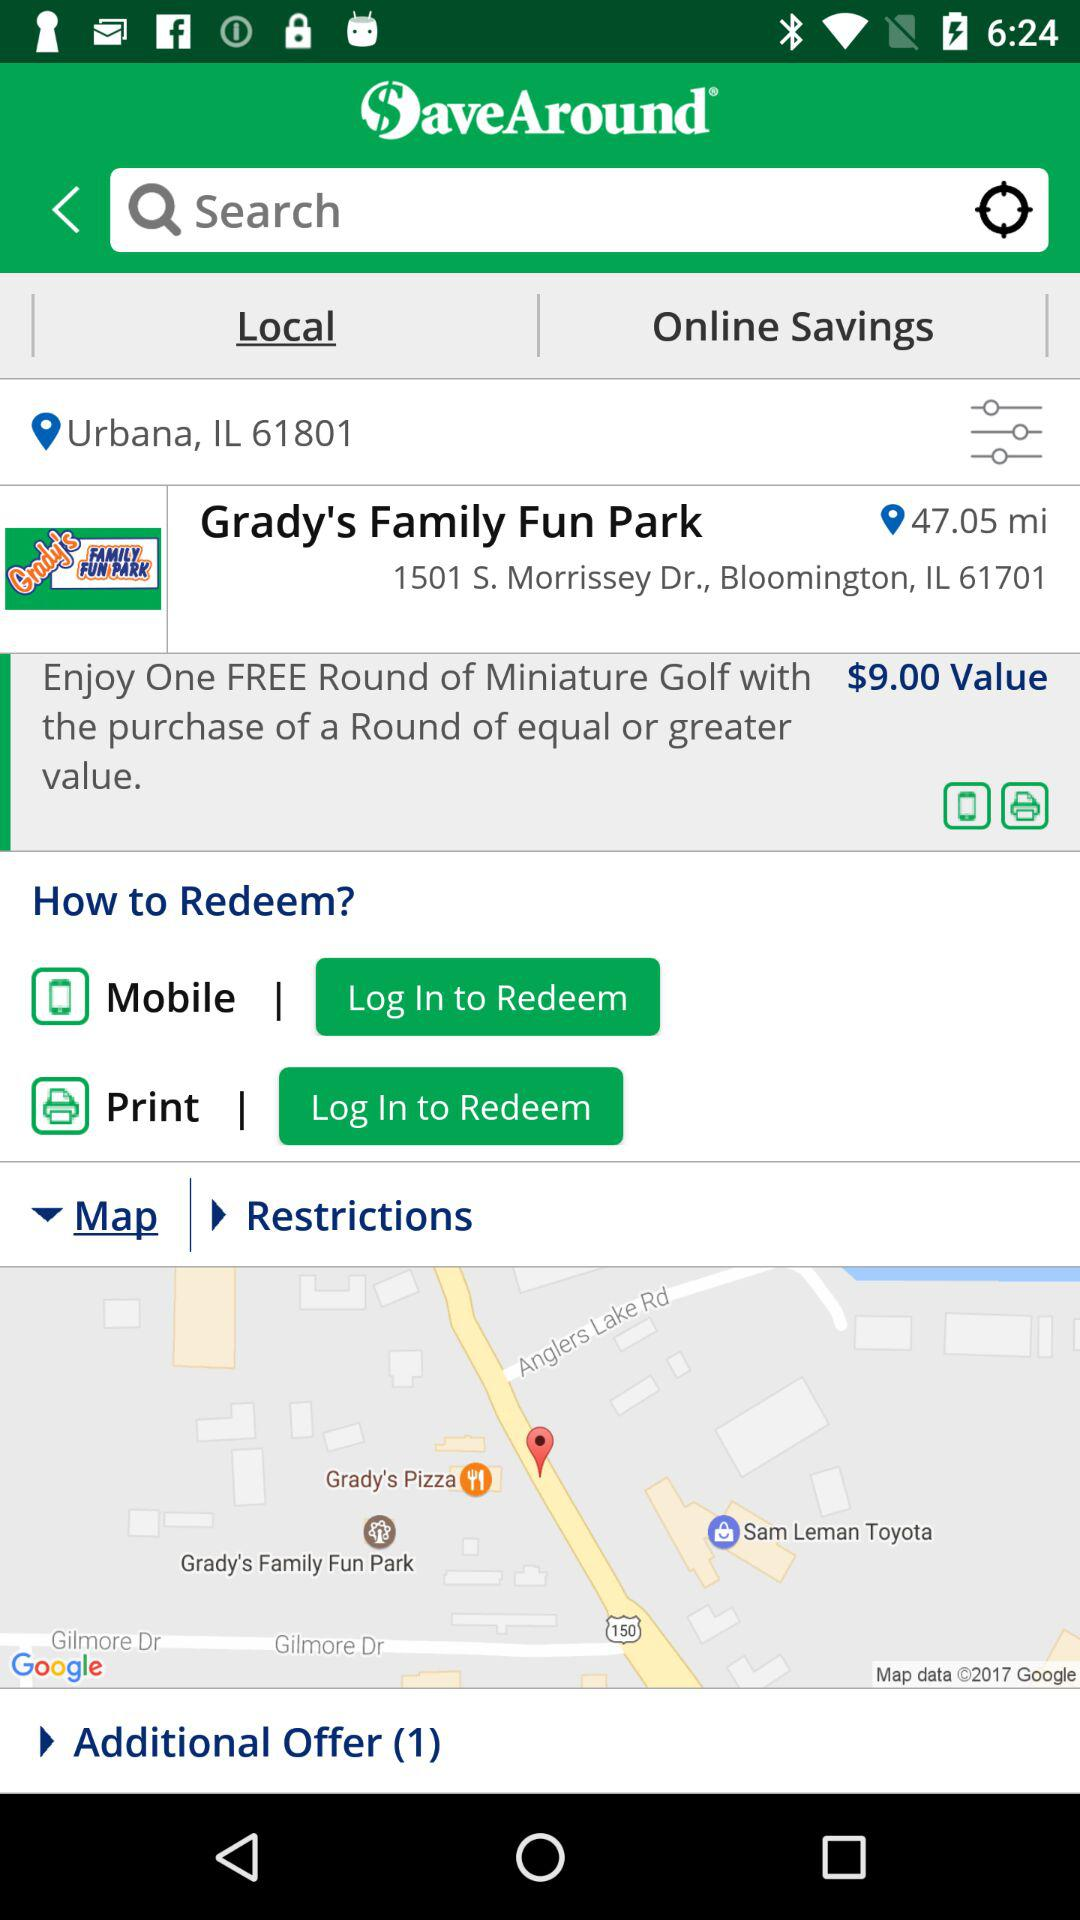What is the pincode of the current location? The pincode is 61801. 